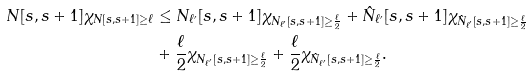<formula> <loc_0><loc_0><loc_500><loc_500>N [ s , s + 1 ] \chi _ { N [ s , s + 1 ] \geq \ell } & \leq N _ { \ell ^ { \prime } } [ s , s + 1 ] \chi _ { N _ { \ell ^ { \prime } } [ s , s + 1 ] \geq \frac { \ell } { 2 } } + \hat { N } _ { \ell ^ { \prime } } [ s , s + 1 ] \chi _ { \hat { N } _ { \ell ^ { \prime } } [ s , s + 1 ] \geq \frac { \ell } { 2 } } \\ & + \frac { \ell } { 2 } \chi _ { N _ { \ell ^ { \prime } } [ s , s + 1 ] \geq \frac { \ell } { 2 } } + \frac { \ell } { 2 } \chi _ { \hat { N } _ { \ell ^ { \prime } } [ s , s + 1 ] \geq \frac { \ell } { 2 } } .</formula> 